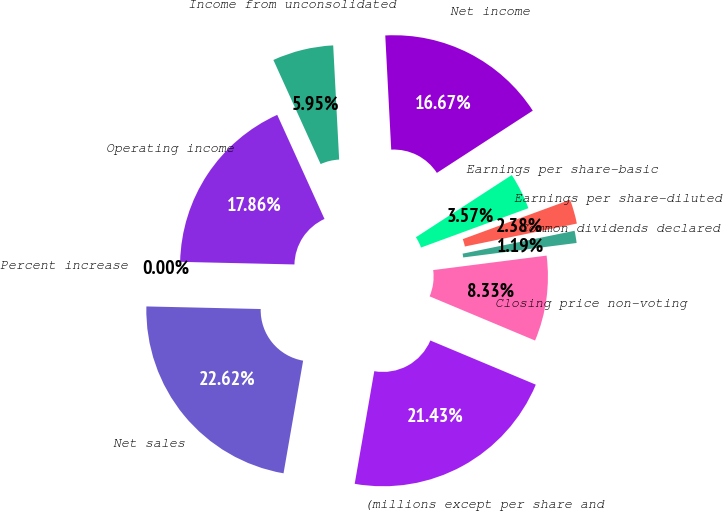Convert chart to OTSL. <chart><loc_0><loc_0><loc_500><loc_500><pie_chart><fcel>(millions except per share and<fcel>Net sales<fcel>Percent increase<fcel>Operating income<fcel>Income from unconsolidated<fcel>Net income<fcel>Earnings per share-basic<fcel>Earnings per share-diluted<fcel>Common dividends declared<fcel>Closing price non-voting<nl><fcel>21.42%<fcel>22.61%<fcel>0.0%<fcel>17.85%<fcel>5.95%<fcel>16.66%<fcel>3.57%<fcel>2.38%<fcel>1.19%<fcel>8.33%<nl></chart> 